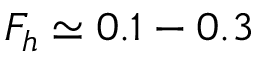Convert formula to latex. <formula><loc_0><loc_0><loc_500><loc_500>F _ { h } \simeq 0 . 1 - 0 . 3</formula> 